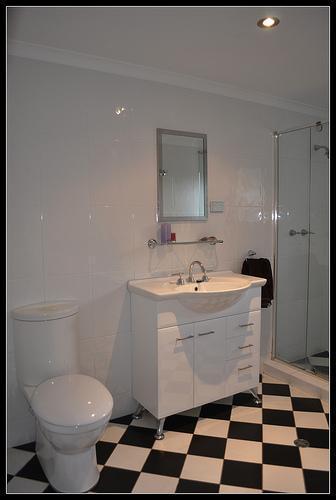How many drawers are there?
Give a very brief answer. 3. 